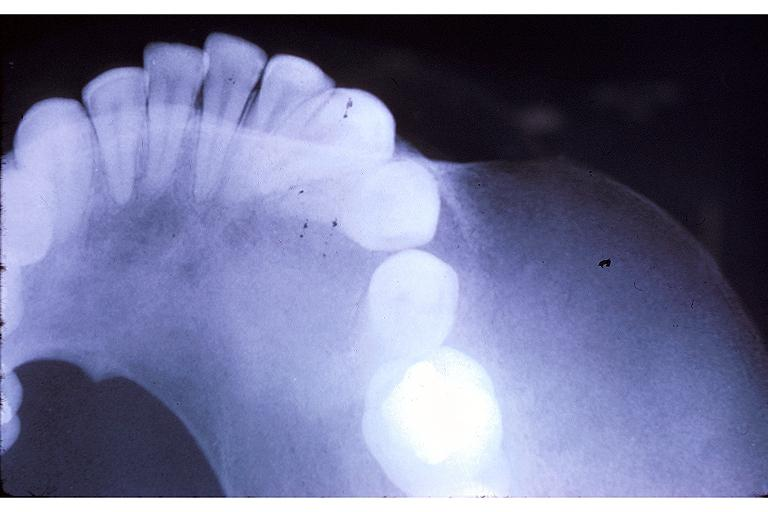where is this?
Answer the question using a single word or phrase. Oral 